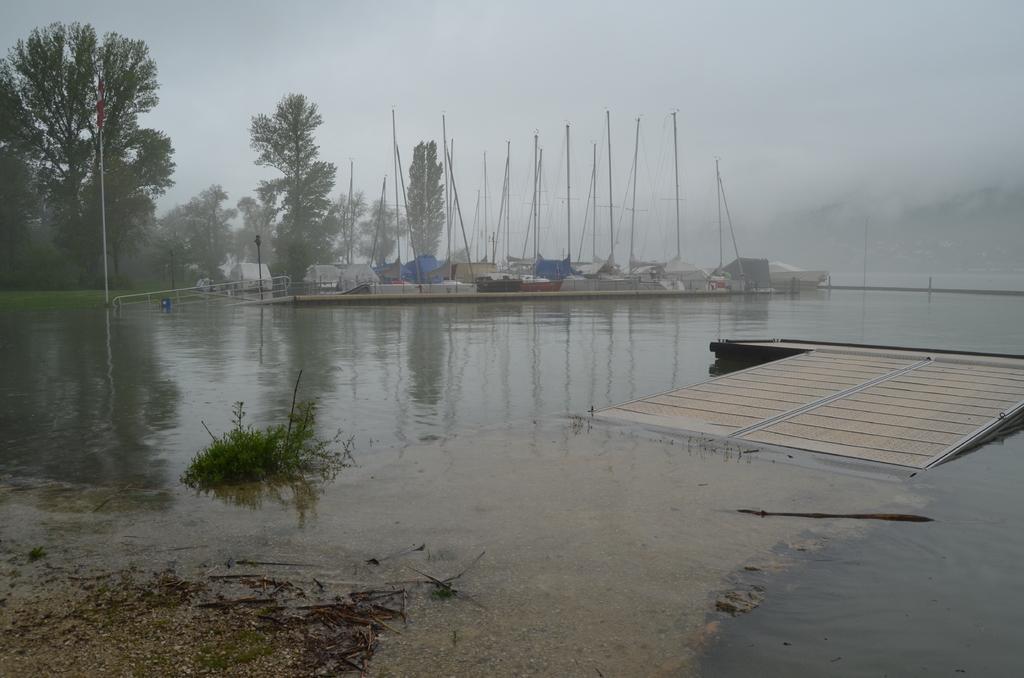Please provide a concise description of this image. In this image I can see water and in background I can see number of tents, poles and trees. 